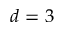Convert formula to latex. <formula><loc_0><loc_0><loc_500><loc_500>d = 3</formula> 